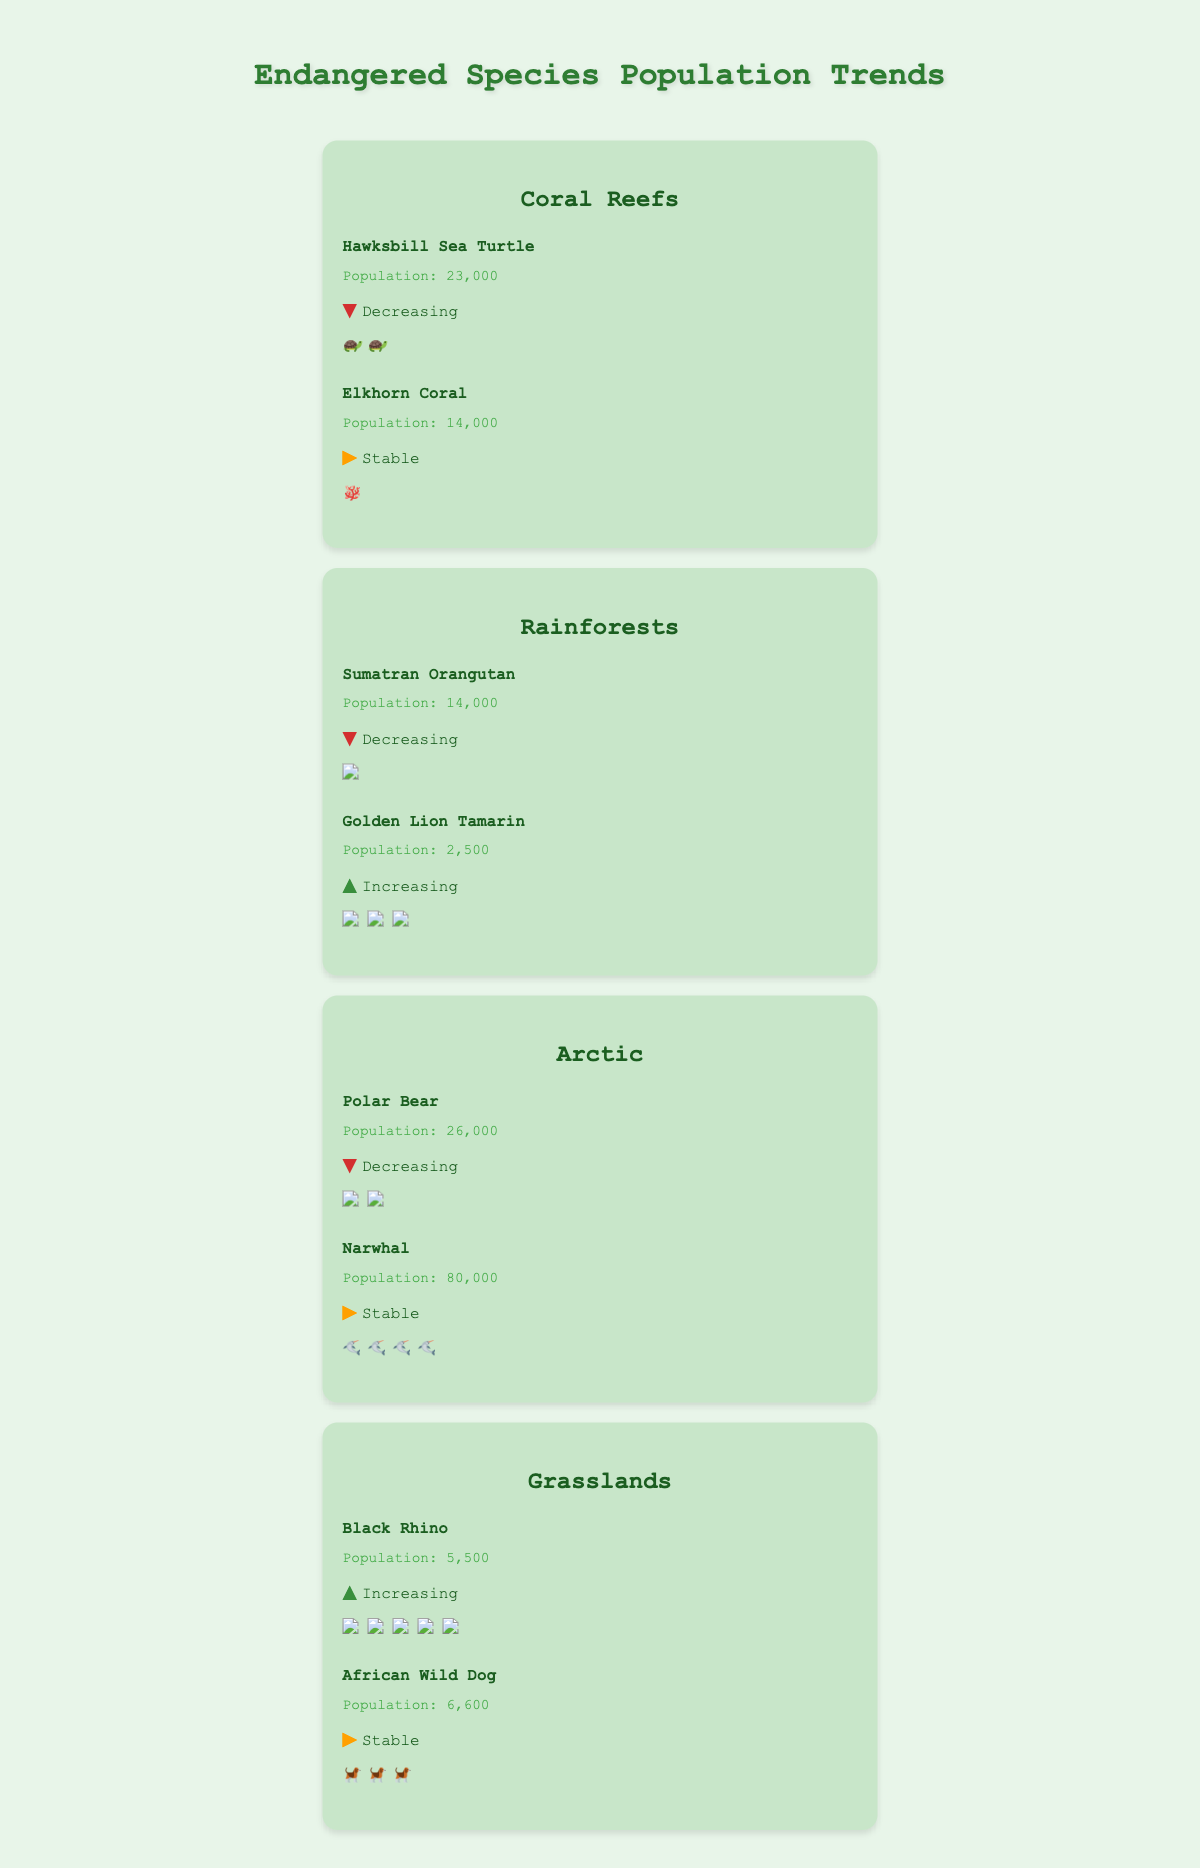What's the population of the Hawksbill Sea Turtle in the Coral Reefs ecosystem? The figure shows the species in each ecosystem, along with their population and trend. The population for the Hawksbill Sea Turtle is written next to its name.
Answer: 23,000 Which species in the Rainforests ecosystem has a stable population trend? The figure assigns a trend icon to each species. We can see an arrow pointing right ("stable") beside the Elkhorn Coral in the Coral Reefs ecosystem. However, there is no species with a stable trend in the Rainforests ecosystem.
Answer: None How many species are there in the Arctic ecosystem, and what are their population trends? The figure shows two species in the Arctic: Polar Bear and Narwhal. The population trends are indicated by arrows: decreasing for Polar Bear and stable for Narwhal.
Answer: 2; Polar Bear (decreasing), Narwhal (stable) Compare the population trend of the Golden Lion Tamarin and the Black Rhino. Which one is increasing? The figure shows the trend for Golden Lion Tamarin with an arrow pointing up ("increasing") and for Black Rhino also with an arrow pointing up ("increasing"). Both have increasing trends.
Answer: Both Which species has the highest population in the Grasslands ecosystem, and what is its population? The Grasslands ecosystem shows the populations for Black Rhino (5,500) and African Wild Dog (6,600). The African Wild Dog has the highest population.
Answer: African Wild Dog; 6,600 What's the total population of species in the Coral Reefs ecosystem? The population of the species in the Coral Reefs ecosystem is Hawksbill Sea Turtle (23,000) and Elkhorn Coral (14,000), so the total population is 23,000 + 14,000.
Answer: 37,000 Which ecosystem contains a species with the highest population, and what species is it? By checking the population numbers, the Narwhal in the Arctic has the highest population of 80,000.
Answer: Arctic; Narwhal Is the population trend of the Sumatran Orangutan improving or worsening? The trend icon for the Sumatran Orangutan shows a downward arrow, indicating that its population trend is worsening.
Answer: Worsening How does the population of Polar Bear compare to the population of Sumatran Orangutan? The figure shows the population for Polar Bear is 26,000, and for Sumatran Orangutan is 14,000. Polar Bear has a larger population.
Answer: Polar Bear > Sumatran Orangutan 